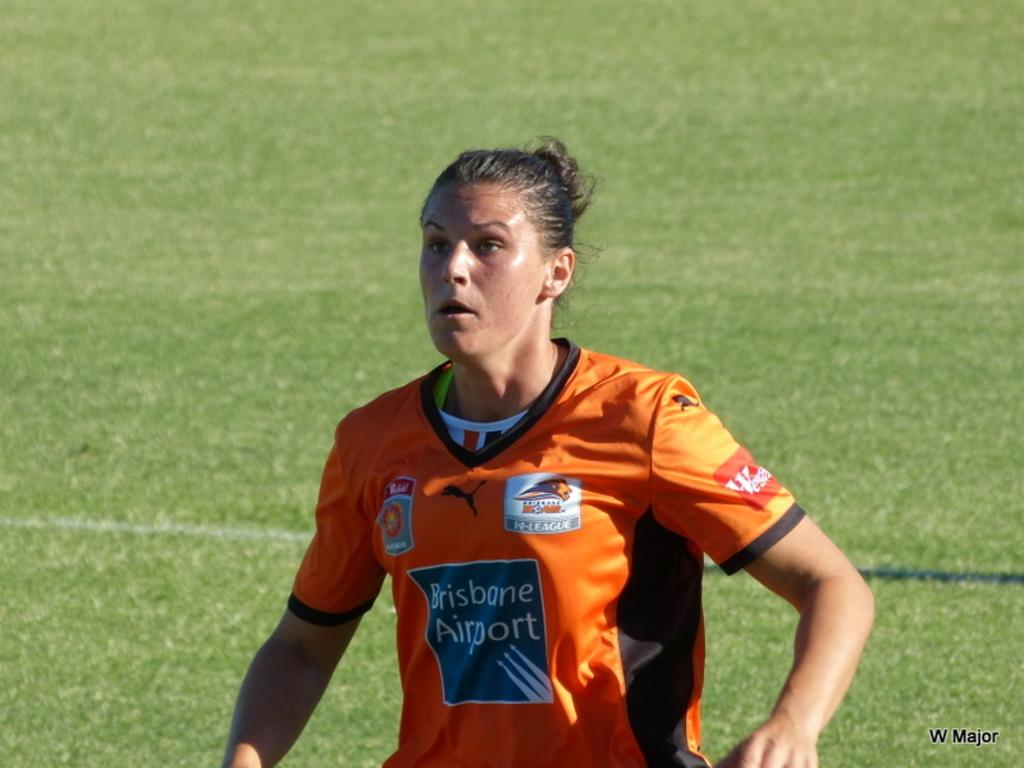<image>
Render a clear and concise summary of the photo. A woman wearing a shirt sponsored by Brisbane Airport is looking straight ahead. 